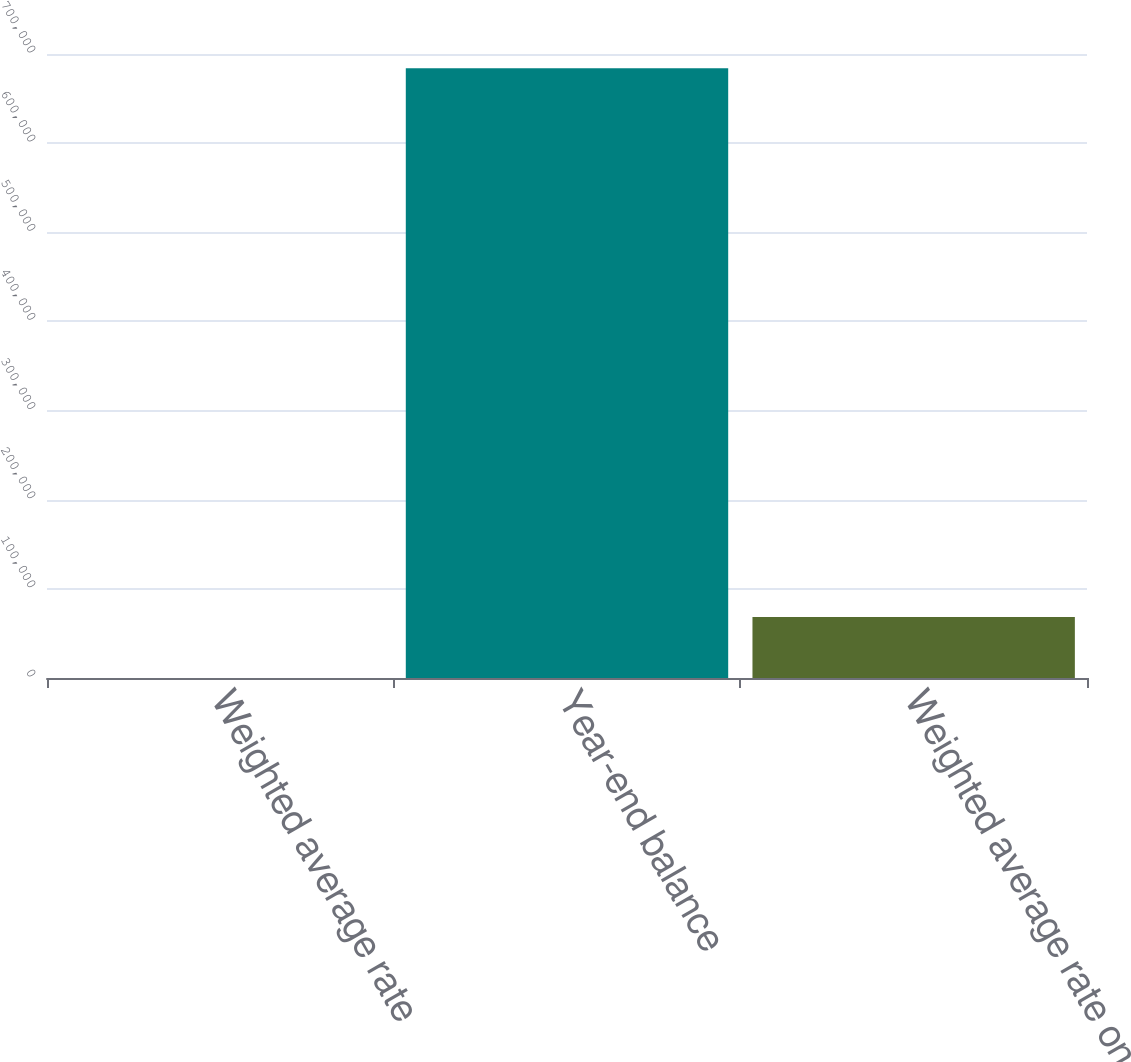Convert chart. <chart><loc_0><loc_0><loc_500><loc_500><bar_chart><fcel>Weighted average rate<fcel>Year-end balance<fcel>Weighted average rate on<nl><fcel>1.33<fcel>683984<fcel>68399.6<nl></chart> 